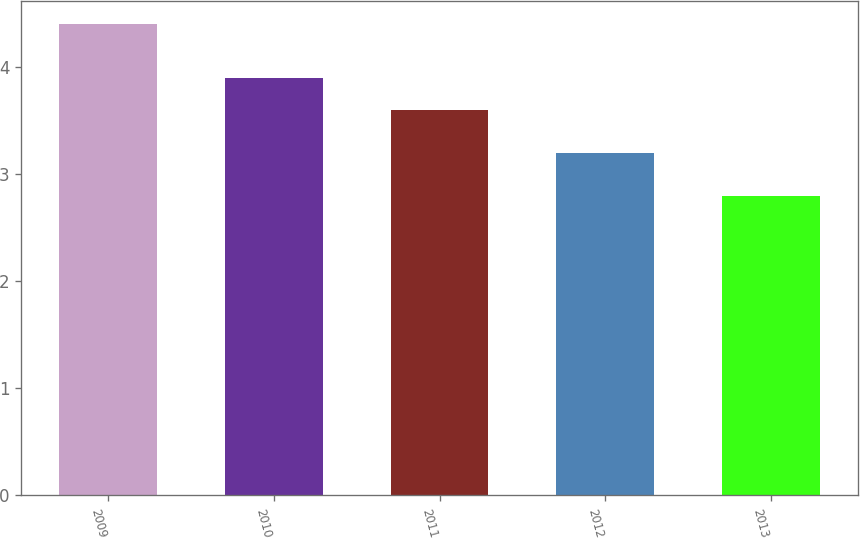Convert chart to OTSL. <chart><loc_0><loc_0><loc_500><loc_500><bar_chart><fcel>2009<fcel>2010<fcel>2011<fcel>2012<fcel>2013<nl><fcel>4.4<fcel>3.9<fcel>3.6<fcel>3.2<fcel>2.8<nl></chart> 